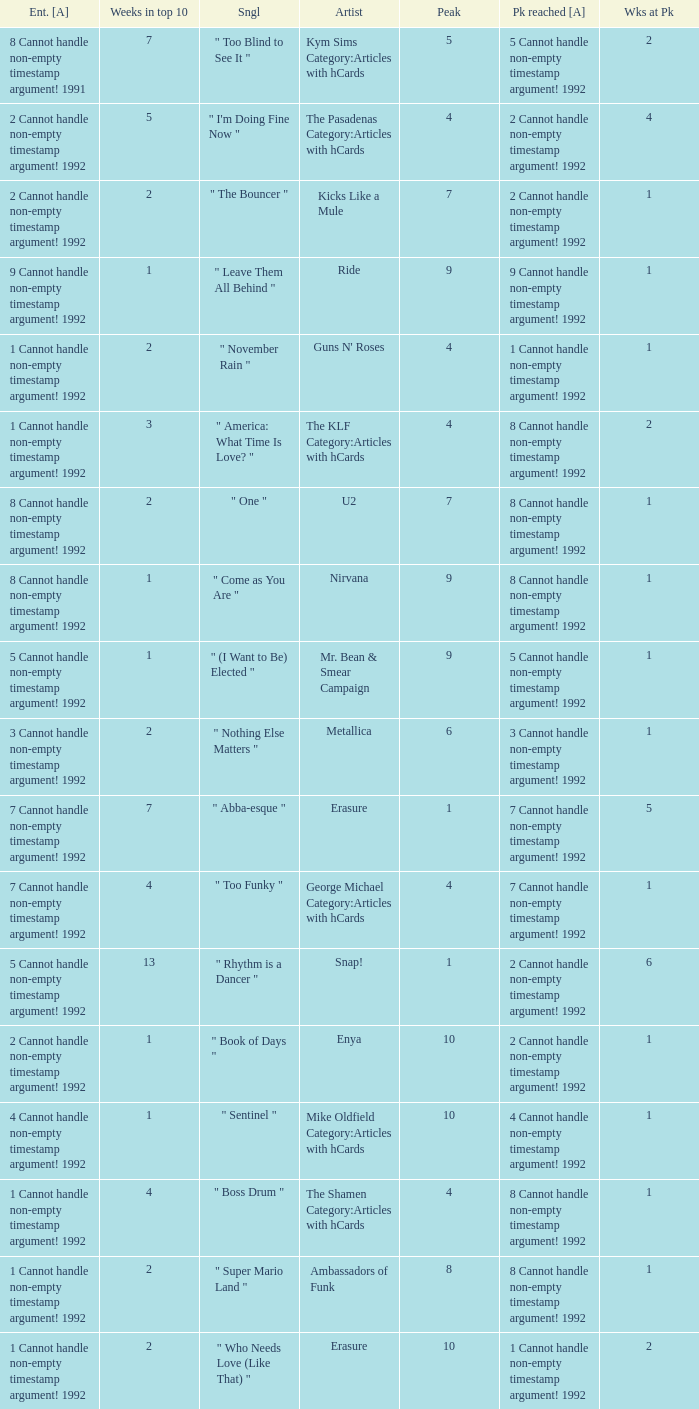If the peak reached is 6 cannot handle non-empty timestamp argument! 1992, what is the entered? 6 Cannot handle non-empty timestamp argument! 1992. 